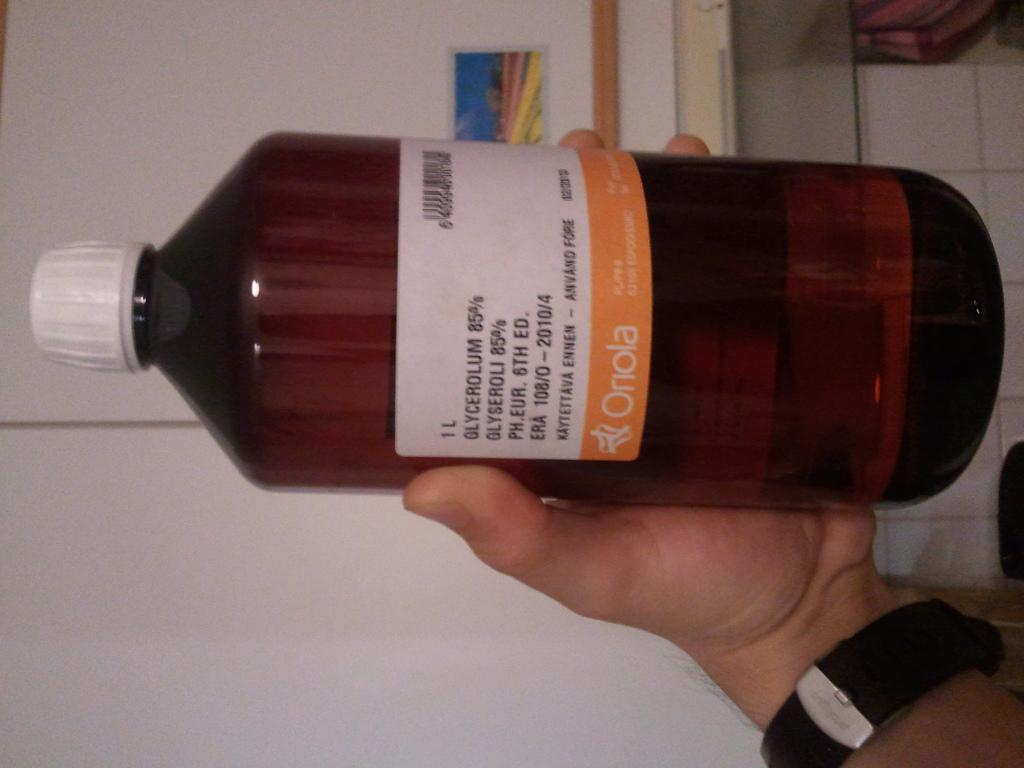<image>
Write a terse but informative summary of the picture. A brown glass chemical bottle says Oriola at the bottom. 